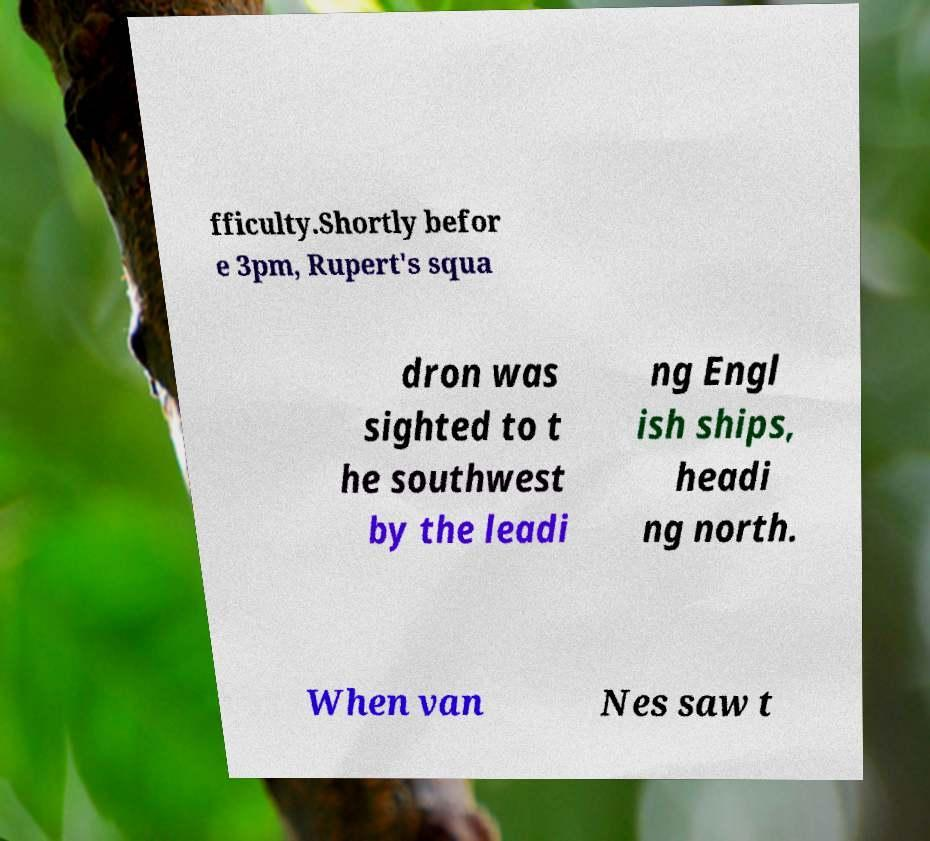I need the written content from this picture converted into text. Can you do that? fficulty.Shortly befor e 3pm, Rupert's squa dron was sighted to t he southwest by the leadi ng Engl ish ships, headi ng north. When van Nes saw t 